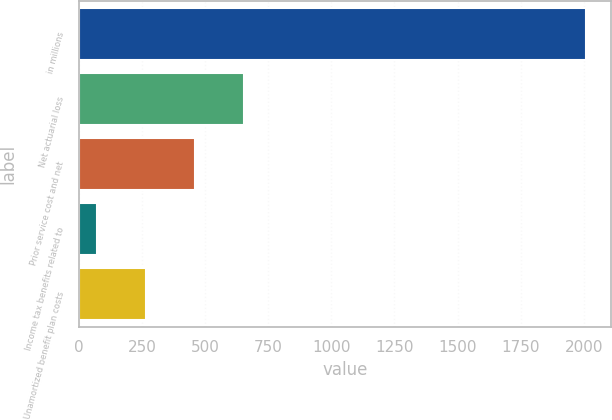Convert chart to OTSL. <chart><loc_0><loc_0><loc_500><loc_500><bar_chart><fcel>in millions<fcel>Net actuarial loss<fcel>Prior service cost and net<fcel>Income tax benefits related to<fcel>Unamortized benefit plan costs<nl><fcel>2008<fcel>652.8<fcel>459.2<fcel>72<fcel>265.6<nl></chart> 